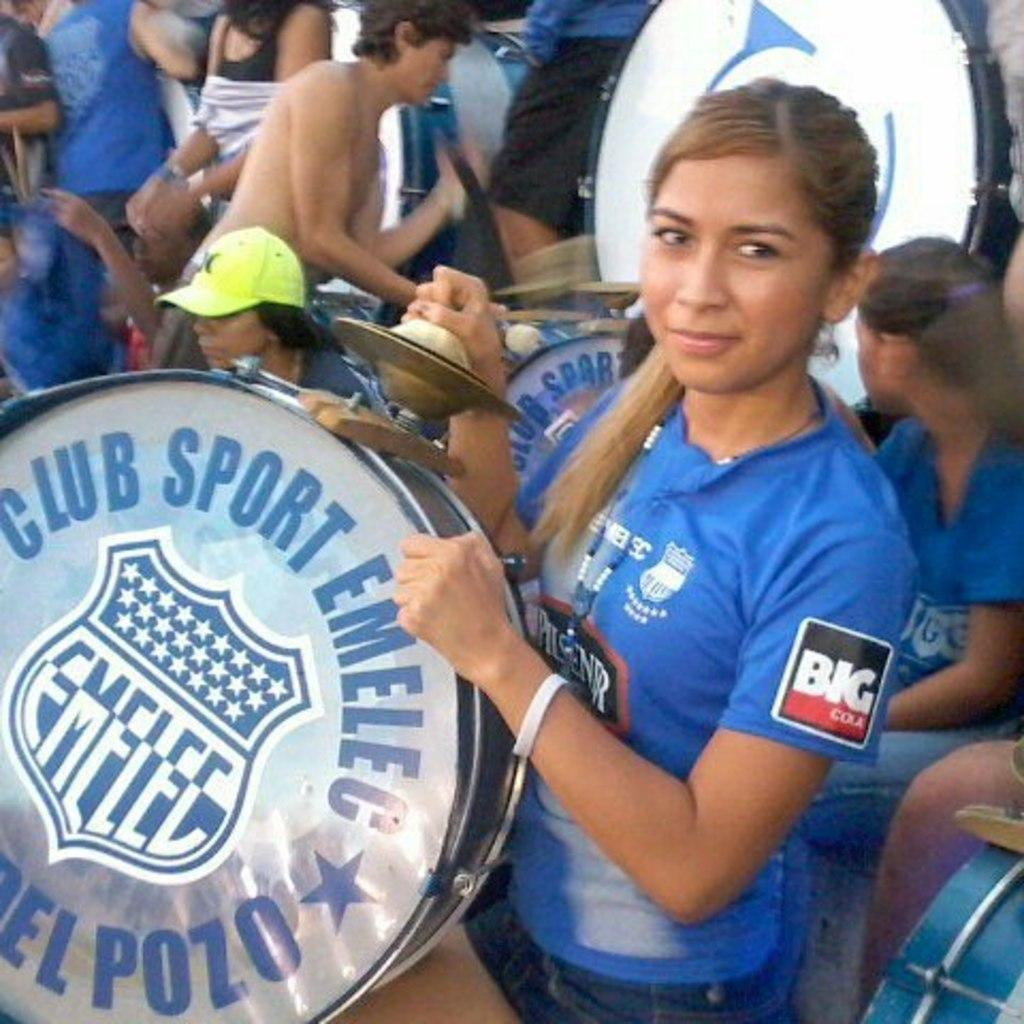What is happening in the image? There are people in the image, and a woman is standing and holding musical instruments. What are the people wearing? Most of the people are wearing blue dresses. Can you see any guns in the image? No, there are no guns present in the image. What types of toys can be seen in the image? There are no toys visible in the image; the focus is on the people and the musical instruments. 